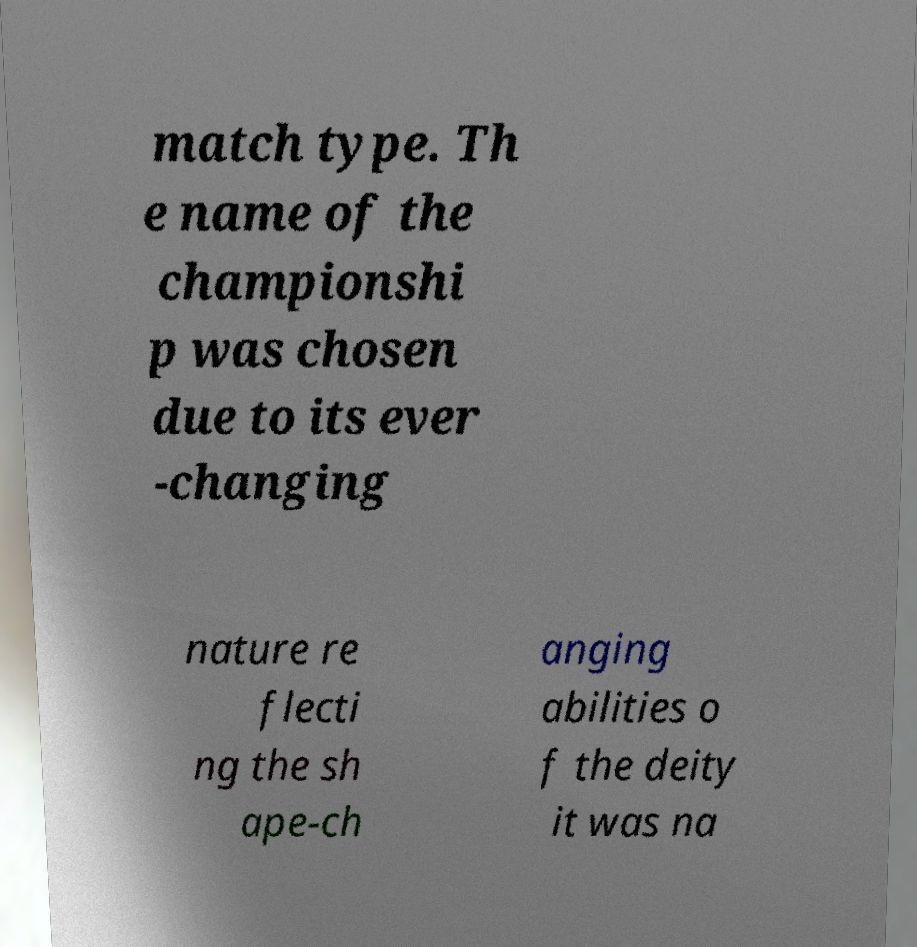There's text embedded in this image that I need extracted. Can you transcribe it verbatim? match type. Th e name of the championshi p was chosen due to its ever -changing nature re flecti ng the sh ape-ch anging abilities o f the deity it was na 